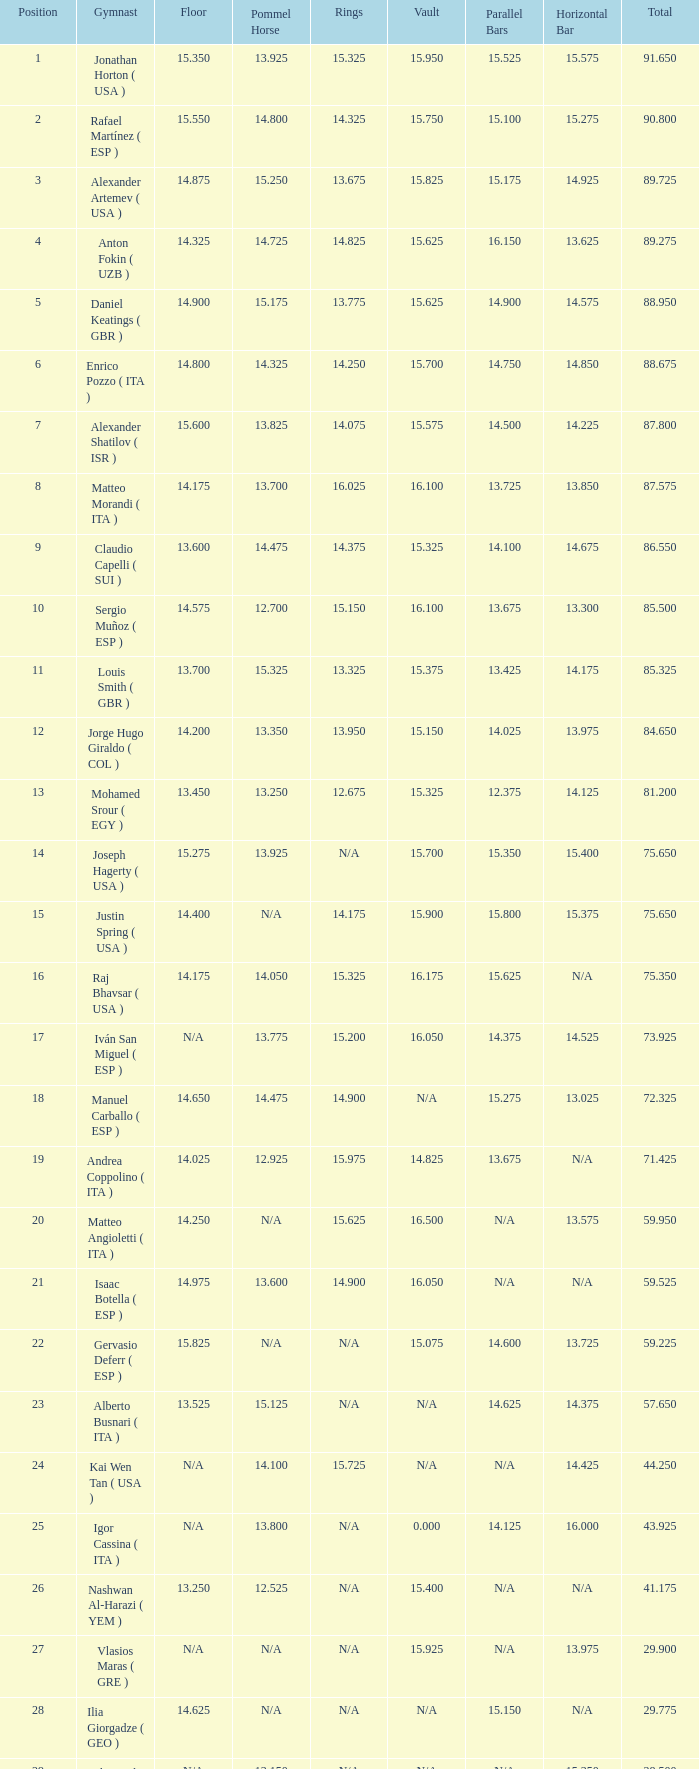If the floor digit is 1 14.025. 